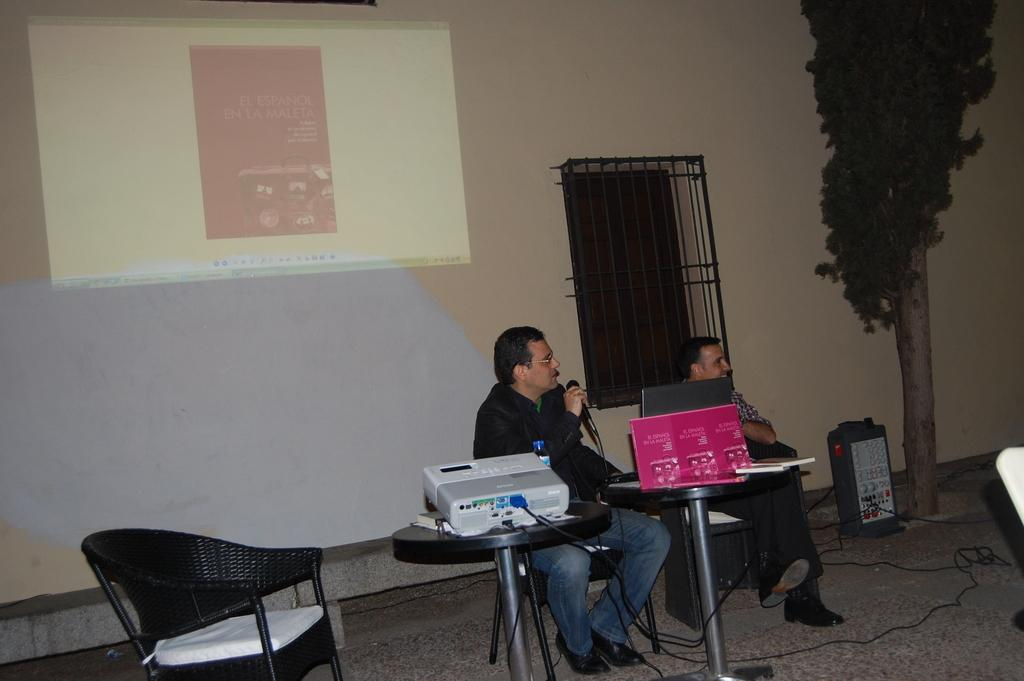How many people are in the image? There are two men in the image. What is one of the men holding in his hand? One man is holding a mic in his hand. What type of furniture can be seen in the image? There are chairs visible in the image. What can be seen in the background of the image? There is a tree and a projector screen on a wall in the background of the image. What type of note is the man playing on the zinc instrument in the image? There is no zinc instrument or note being played in the image; the man is holding a mic. 